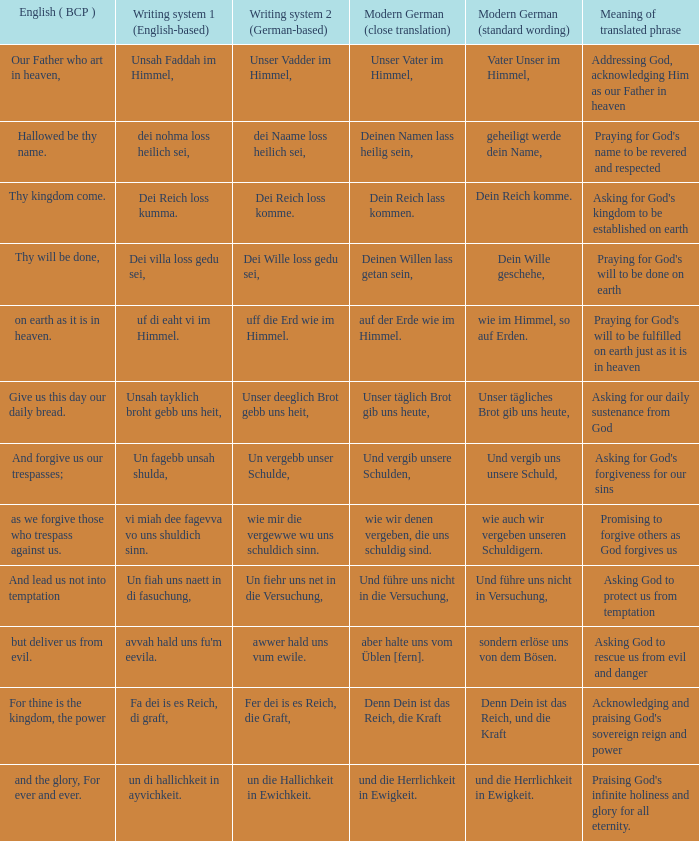What is the english (bcp) phrase "for thine is the kingdom, the power" in modern german with standard wording? Denn Dein ist das Reich, und die Kraft. 